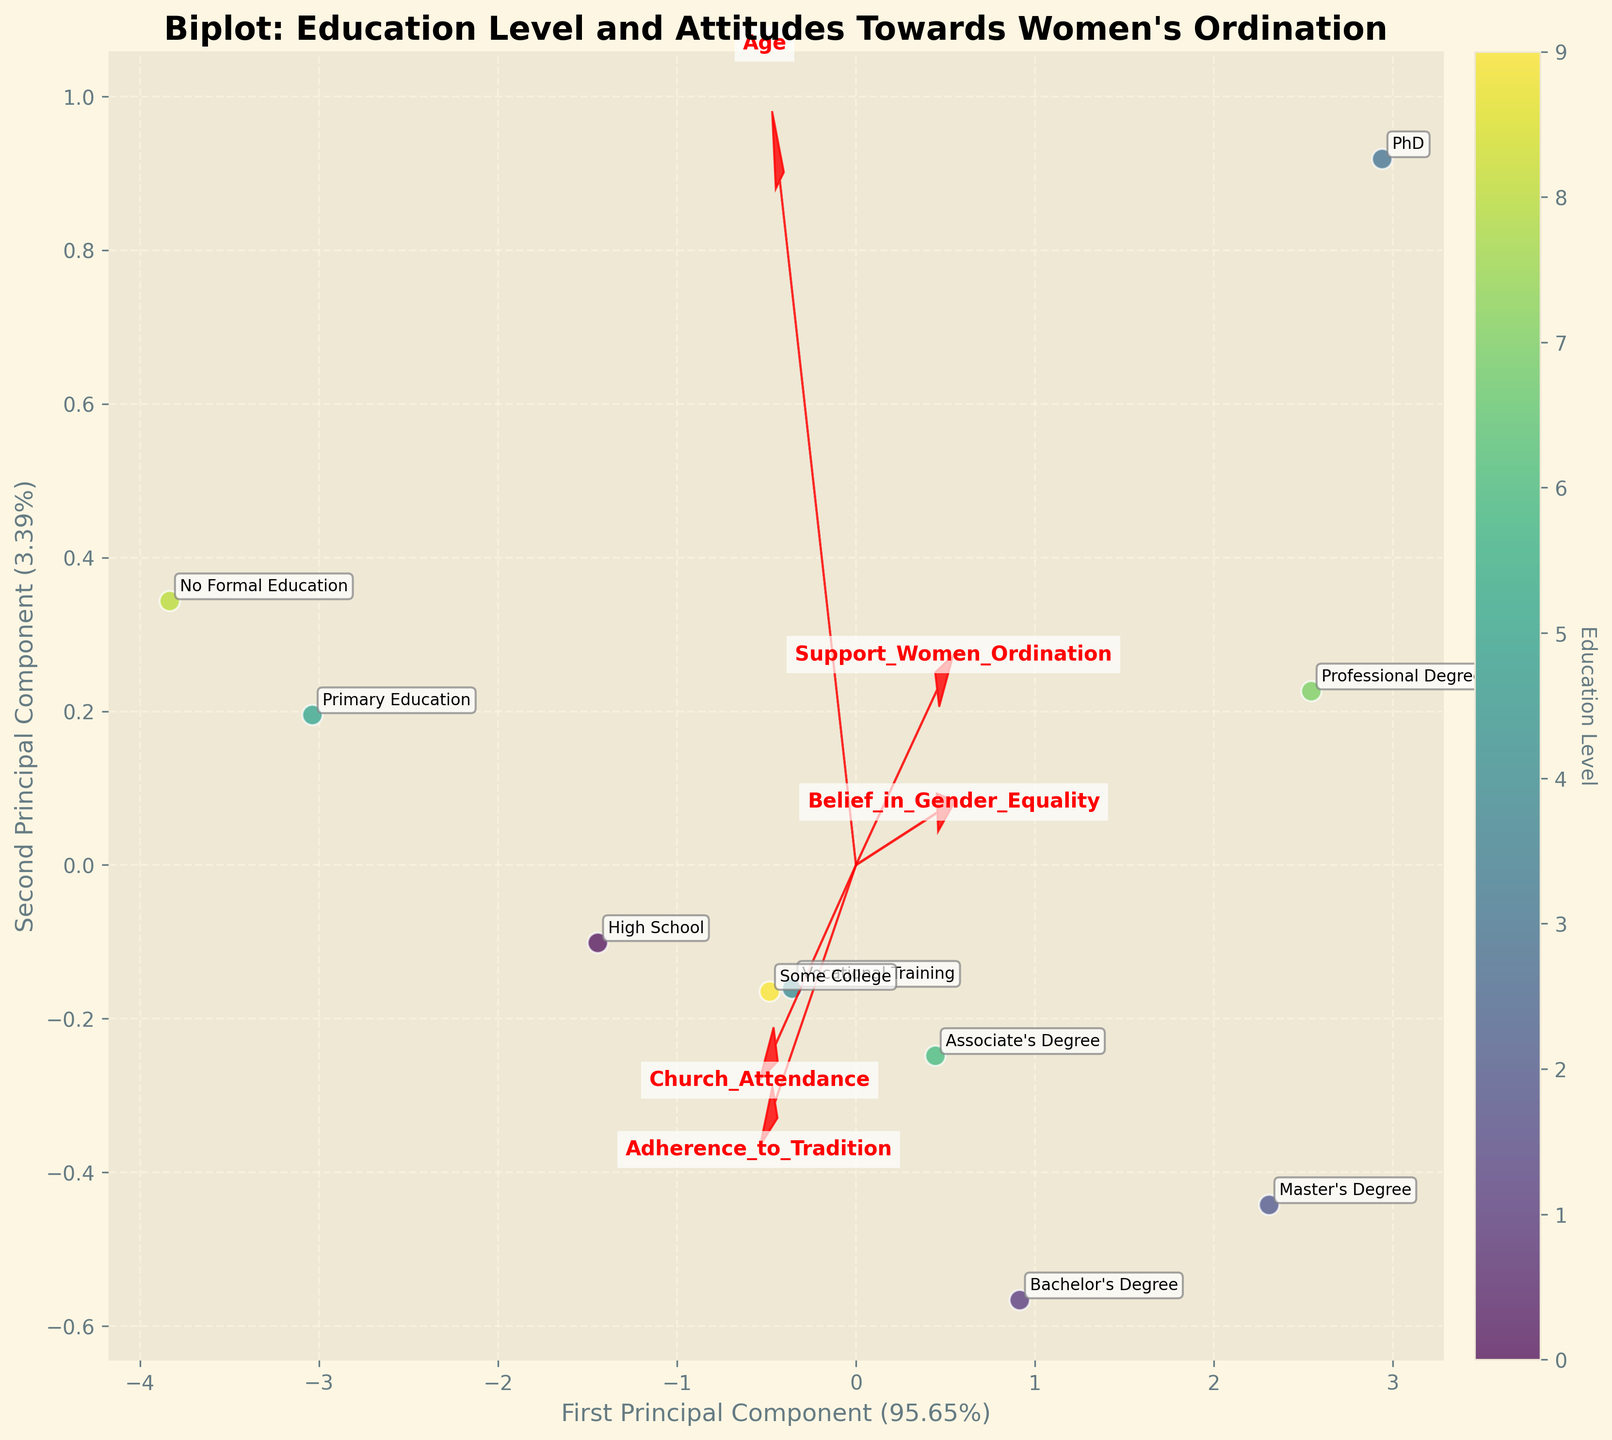What is the title of the biplot? The title is the large text at the top of the figure, which summarizes the content and purpose of the plot.
Answer: Biplot: Education Level and Attitudes Towards Women's Ordination How many educational levels are displayed in the biplot? Count the different text annotations representing educational levels in the plot.
Answer: 10 Which educational level shows the highest support for women's ordination? Look for the text annotation located furthest in the direction indicated by the "Support_Women_Ordination" vector.
Answer: PhD Which feature vector points towards the bottom-right quadrant of the biplot? Observe the direction of the arrows representing the features, and identify which one points towards the bottom-right quadrant.
Answer: Church_Attendance What is the first principal component's explained variance ratio? The explained variance ratio of the first principal component can be found on the x-axis label.
Answer: 56.47% Compare the support for women's ordination between those with a Bachelor's Degree and those with no formal education. Who supports it more? Locate the annotations for "Bachelor's Degree" and "No Formal Education," then compare their positions relative to the "Support_Women_Ordination" vector.
Answer: Bachelor's Degree Which two educational levels are closest to each other in the biplot? Identify the pair of text annotations that are situated nearest to one another within the biplot.
Answer: Some College and Associate's Degree What does the length of the feature vectors in the biplot represent? Vectors indicate the importance of each feature in the principal components. Longer vectors signify greater influence.
Answer: Feature importance Which educational level exhibits the highest adherence to tradition? Find the annotation that aligns most closely with the direction of the "Adherence_to_Tradition" vector.
Answer: No Formal Education Which educational level has the lowest church attendance relative to their position? Identify the annotation that lies furthest away from the "Church_Attendance" vector.
Answer: PhD 